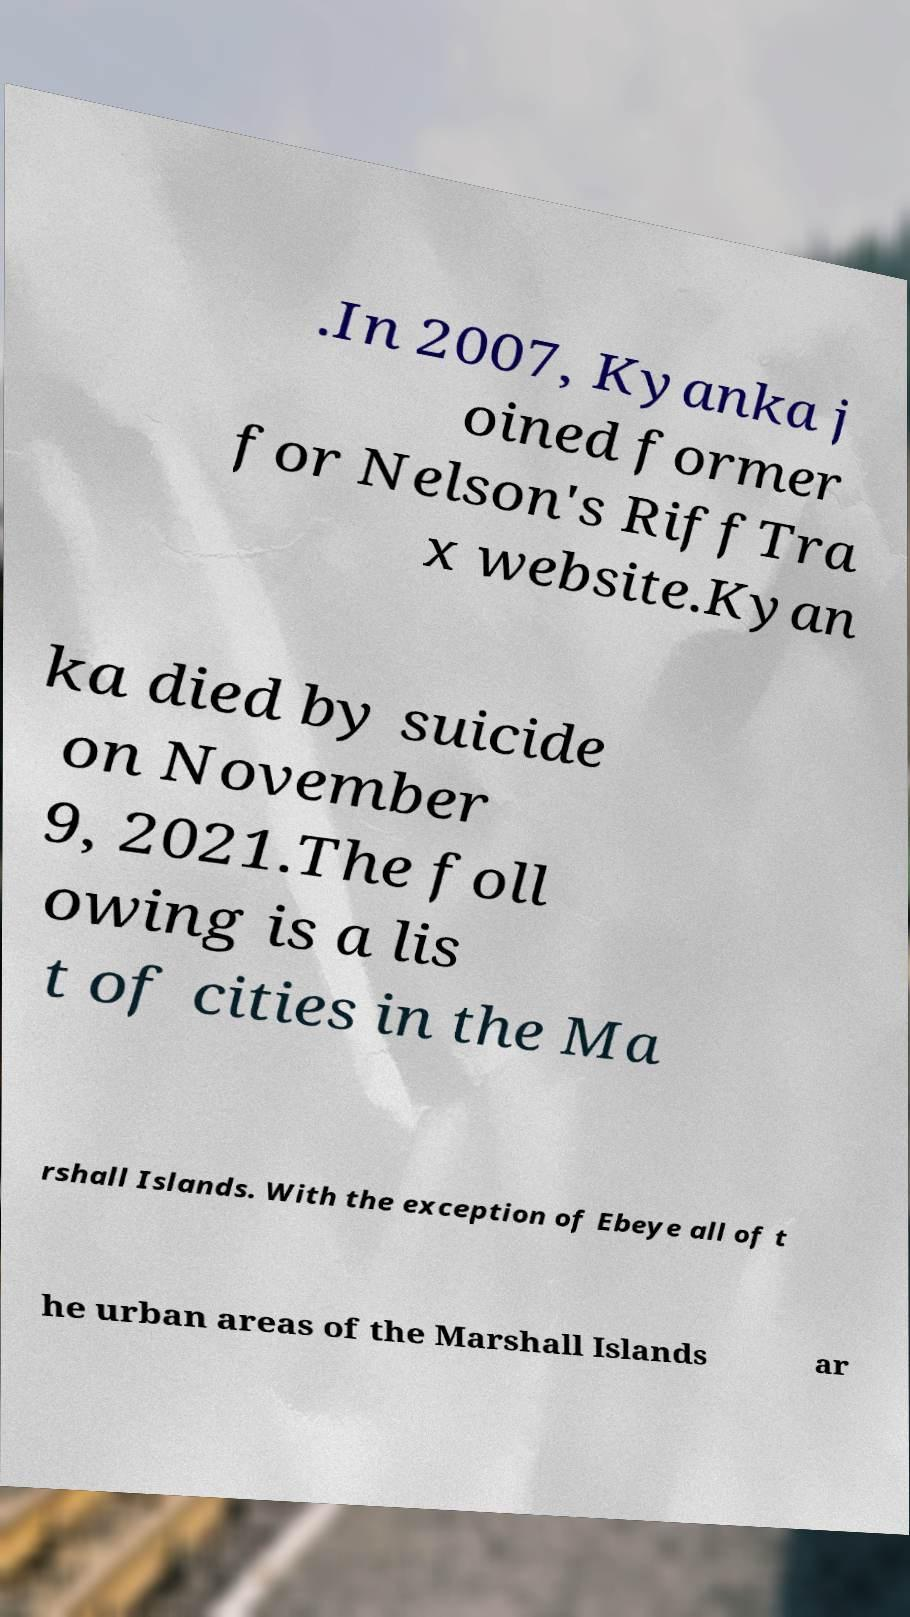Can you read and provide the text displayed in the image?This photo seems to have some interesting text. Can you extract and type it out for me? .In 2007, Kyanka j oined former for Nelson's RiffTra x website.Kyan ka died by suicide on November 9, 2021.The foll owing is a lis t of cities in the Ma rshall Islands. With the exception of Ebeye all of t he urban areas of the Marshall Islands ar 